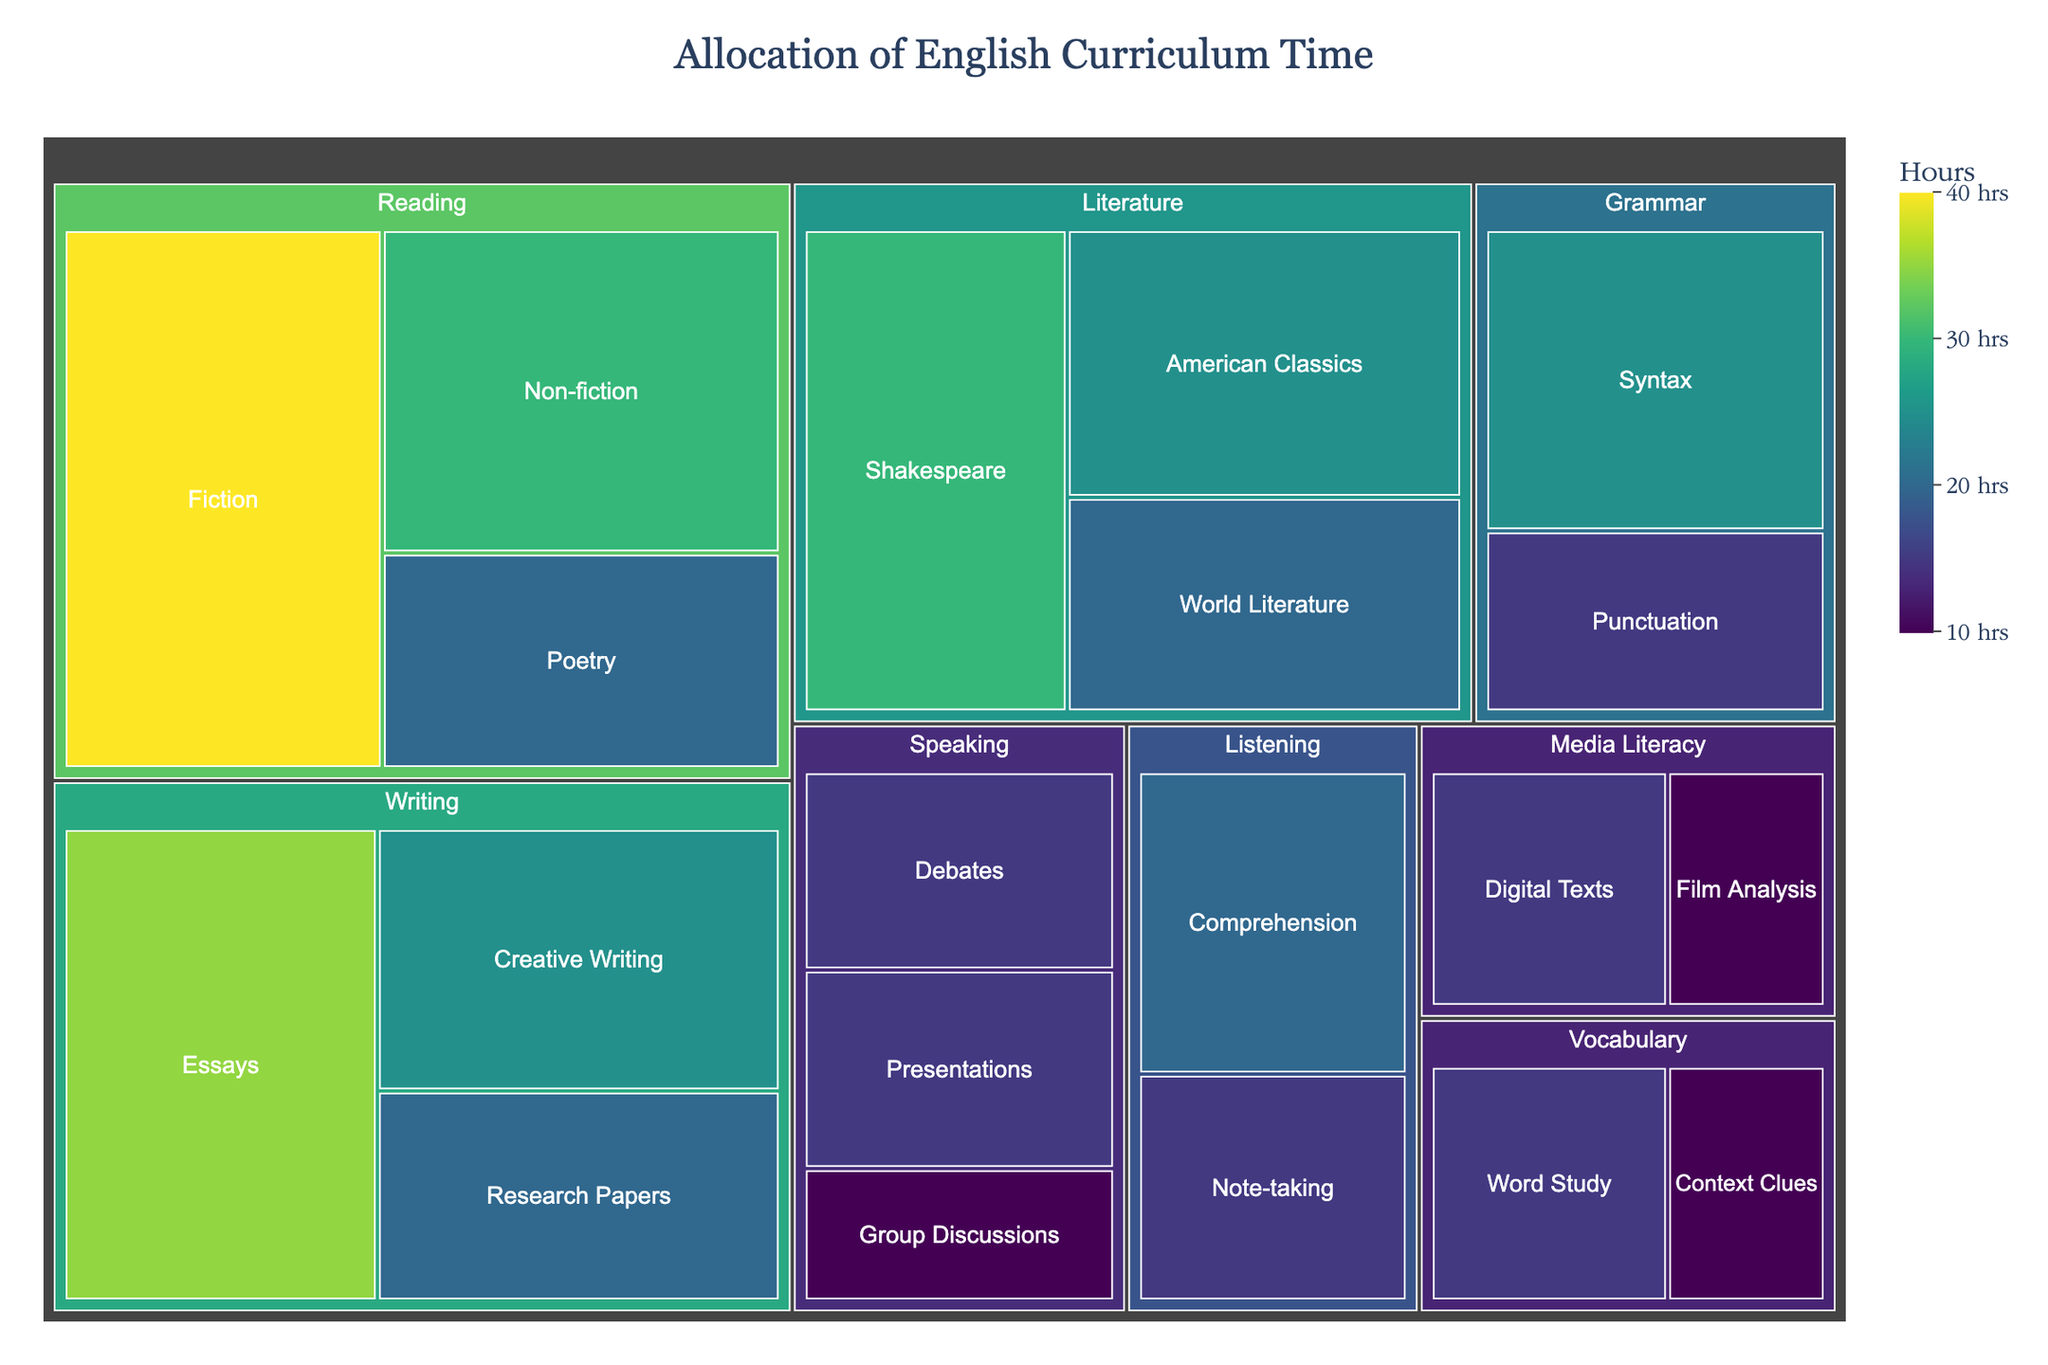What's the title of the figure? The title is typically displayed at the top of the treemap
Answer: Allocation of English Curriculum Time Which category receives the most curriculum time? By looking at the largest section in the treemap, we can identify which category has the highest number of hours. The "Reading" section appears to dominate
Answer: Reading How many hours are allocated to Writing essays? Locate the Writing section in the treemap and subcategory essays to see its hours
Answer: 35 Which has more hours: Grammar or Vocabulary? Compare the size of the Grammar section with the Vocabulary section in the treemap
Answer: Grammar (40 hours vs. 25 hours) What is the total time allocated to the Literature category? Sum the hours of all the subcategories under Literature: Shakespeare (30), American Classics (25), and World Literature (20)
Answer: 75 How do the hours spent on Speaking presentations compare to Speaking debates? Locate the Speaking section, then compare the subcategories presentations (15) and debates (15); they should be the same size
Answer: They are equal What is the difference in hours allocated between Listening comprehension and Listening note-taking? Locate both subcategories under Listening and subtract note-taking (15) from comprehension (20)
Answer: 5 Which subcategory within Media Literacy has fewer hours? Compare the subcategories of digital texts and film analysis to determine which has fewer hours
Answer: Film Analysis What is the total time allocated to Writing? Sum the hours of all subcategories under Writing: Essays (35), Creative Writing (25), and Research Papers (20)
Answer: 80 Which subcategory in Reading has the second-highest allocation of time? Locate the Reading section and compare the subcategories; Fiction (40), Non-fiction (30), and Poetry (20), the second highest is Non-fiction
Answer: Non-fiction 